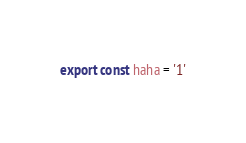<code> <loc_0><loc_0><loc_500><loc_500><_JavaScript_>export const haha = '1'</code> 